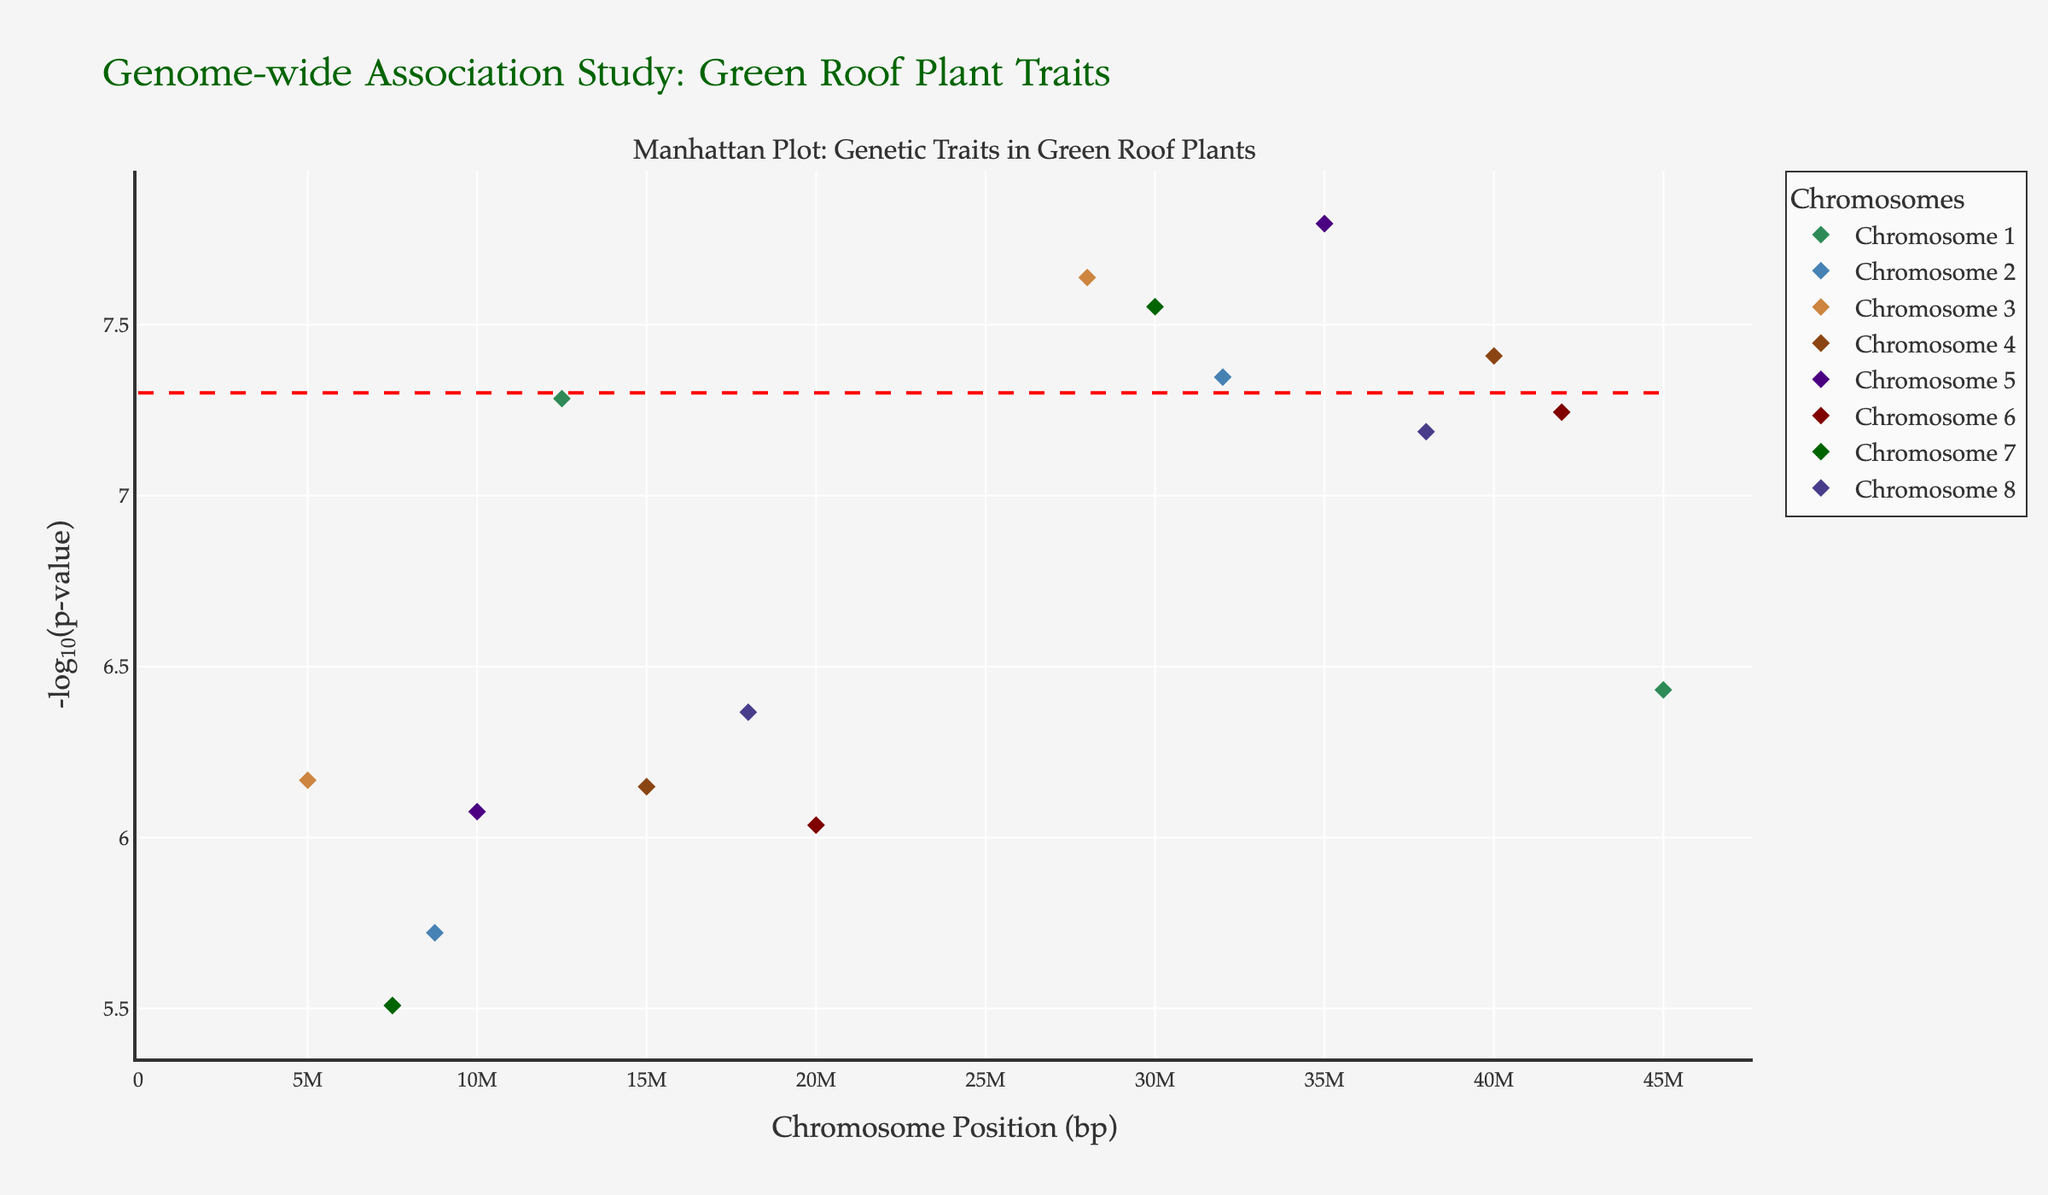What is the title of the manhattan plot? The title of a plot is usually placed at the top and it summarizes the main purpose or content of the plot. Here, it is "Genome-wide Association Study: Green Roof Plant Traits."
Answer: Genome-wide Association Study: Green Roof Plant Traits What does the y-axis represent in the Manhattan Plot? The y-axis in Manhattan Plots typically represents the negative logarithm of the p-value (-log10(p-value)). This transformation is used to display very small p-values on a more interpretable scale.
Answer: -log10(p-value) How many chromosomes are represented in this study? The data includes information on chromosomes 1 through 8, so there are a total of 8 chromosomes represented in the Manhattan Plot.
Answer: 8 Which chromosome has the most significant p-value? The significance of a p-value in the Manhattan Plot can be determined by the height of the data point. The lower the p-value, the higher the -log10(p-value) value. This can be observed at the peak of the y-axis. For this plot, Chromosome 2 has a data point with one of the highest -log10(p-value), at position 32000000.
Answer: Chromosome 2 Which trait is associated with the most significant p-value on Chromosome 5? For Chromosome 5, the data point with the highest -log10(p-value) value is associated with the position 35000000, linked to the Opuntia1 gene. This is related to the trait "CO2 sequestration."
Answer: CO2 sequestration Compare the p-value significance thresholds across chromosomes. Do any markers exceed this threshold? The threshold line is represented by a horizontal dashed line at -log10(p-value) of 5e-8. We need to check if any data points rise above this threshold across all chromosomes. Markers on Chromosome 1 at position 12500000, Chromosome 2 at position 32000000, Chromosome 3 at position 28000000, Chromosome 4 at position 40000000, Chromosome 5 at position 35000000, Chromosome 6 at position 42000000, and Chromosome 7 at position 30000000 all exceed the significance threshold.
Answer: Yes What is the position on Chromosome 3 with the highest -log10(p-value) value, and what is the associated gene and trait? On Chromosome 3, the data point with the highest -log10(p-value) value is at position 28000000. The associated gene is Carex1 and the trait is Pollution tolerance.
Answer: 28000000, Carex1, Pollution tolerance Identify one gene related to Urban Heat Island Mitigation and its chromosome number. The only gene related to Urban Heat Island Mitigation in the dataset is Phedimus1, which is located on Chromosome 6.
Answer: Phedimus1, Chromosome 6 